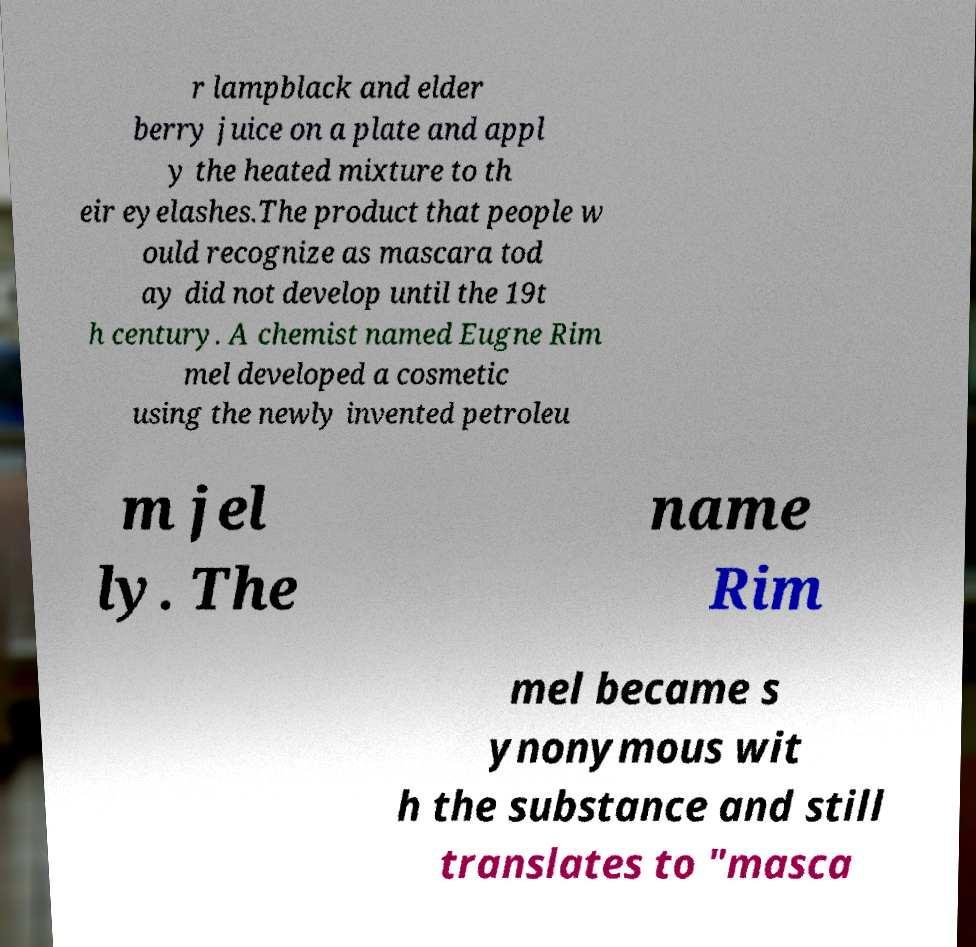For documentation purposes, I need the text within this image transcribed. Could you provide that? r lampblack and elder berry juice on a plate and appl y the heated mixture to th eir eyelashes.The product that people w ould recognize as mascara tod ay did not develop until the 19t h century. A chemist named Eugne Rim mel developed a cosmetic using the newly invented petroleu m jel ly. The name Rim mel became s ynonymous wit h the substance and still translates to "masca 